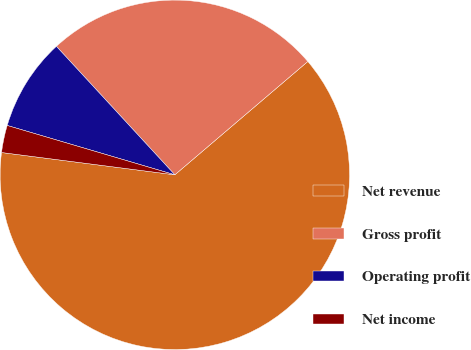Convert chart. <chart><loc_0><loc_0><loc_500><loc_500><pie_chart><fcel>Net revenue<fcel>Gross profit<fcel>Operating profit<fcel>Net income<nl><fcel>63.27%<fcel>25.62%<fcel>8.59%<fcel>2.52%<nl></chart> 